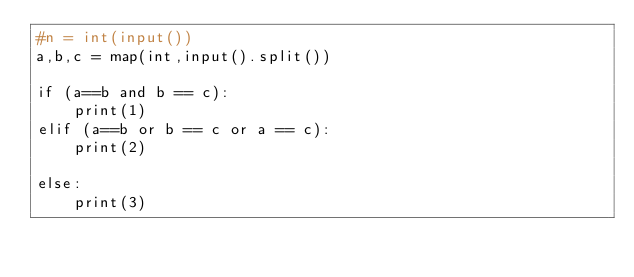Convert code to text. <code><loc_0><loc_0><loc_500><loc_500><_Python_>#n = int(input())
a,b,c = map(int,input().split())

if (a==b and b == c):
    print(1)
elif (a==b or b == c or a == c):
    print(2)

else:
    print(3)

</code> 